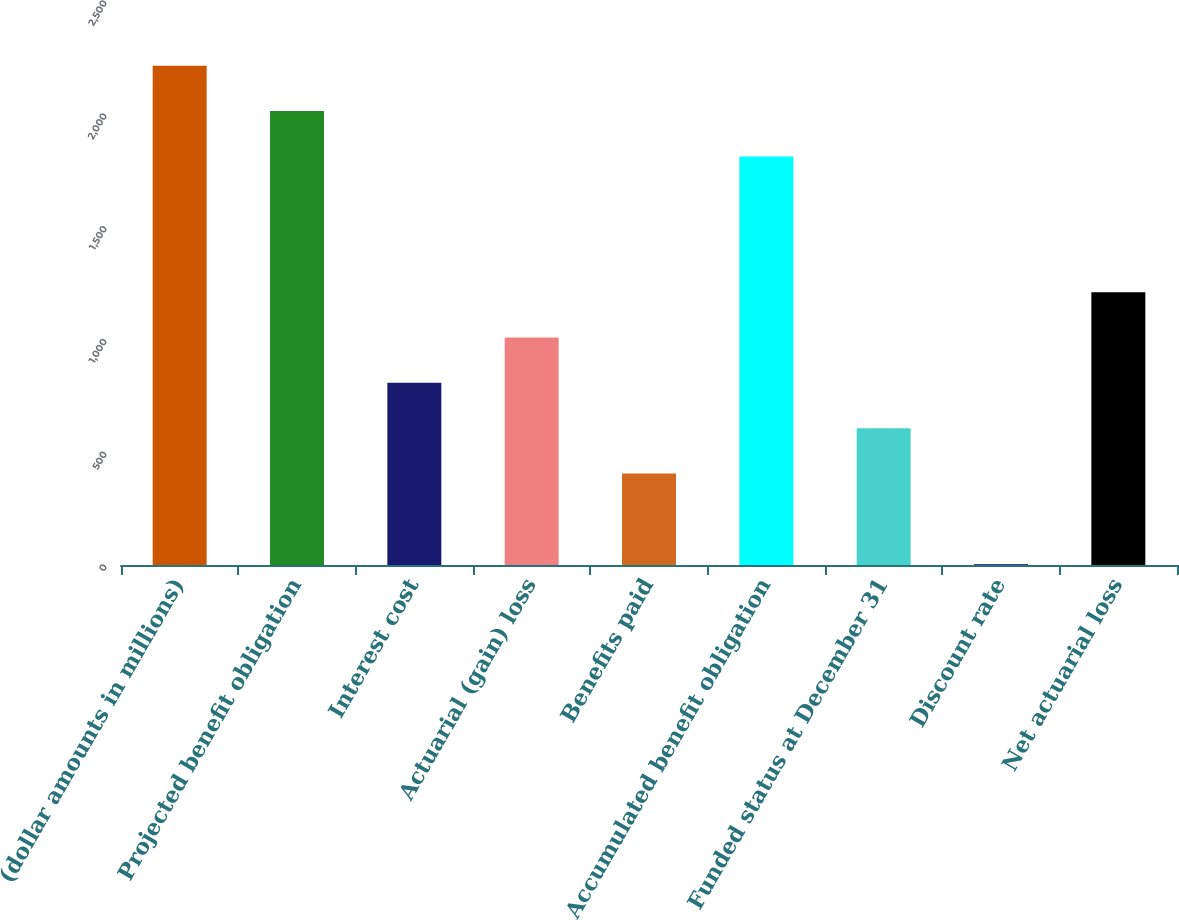Convert chart. <chart><loc_0><loc_0><loc_500><loc_500><bar_chart><fcel>(dollar amounts in millions)<fcel>Projected benefit obligation<fcel>Interest cost<fcel>Actuarial (gain) loss<fcel>Benefits paid<fcel>Accumulated benefit obligation<fcel>Funded status at December 31<fcel>Discount rate<fcel>Net actuarial loss<nl><fcel>2212.78<fcel>2012<fcel>807.32<fcel>1008.1<fcel>405.76<fcel>1811.22<fcel>606.54<fcel>4.2<fcel>1208.88<nl></chart> 